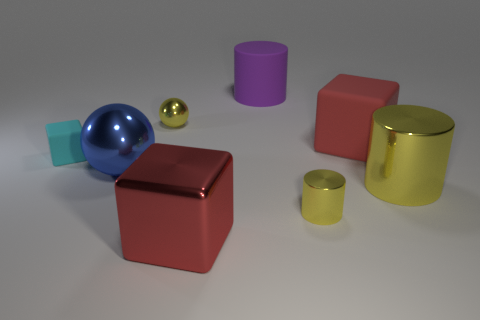Subtract all large blocks. How many blocks are left? 1 Subtract 1 cylinders. How many cylinders are left? 2 Add 2 small cyan matte cubes. How many objects exist? 10 Subtract all purple cylinders. How many cylinders are left? 2 Subtract 0 brown balls. How many objects are left? 8 Subtract all cubes. How many objects are left? 5 Subtract all cyan cylinders. Subtract all purple blocks. How many cylinders are left? 3 Subtract all blue cylinders. How many purple blocks are left? 0 Subtract all tiny cyan blocks. Subtract all tiny yellow objects. How many objects are left? 5 Add 5 big red objects. How many big red objects are left? 7 